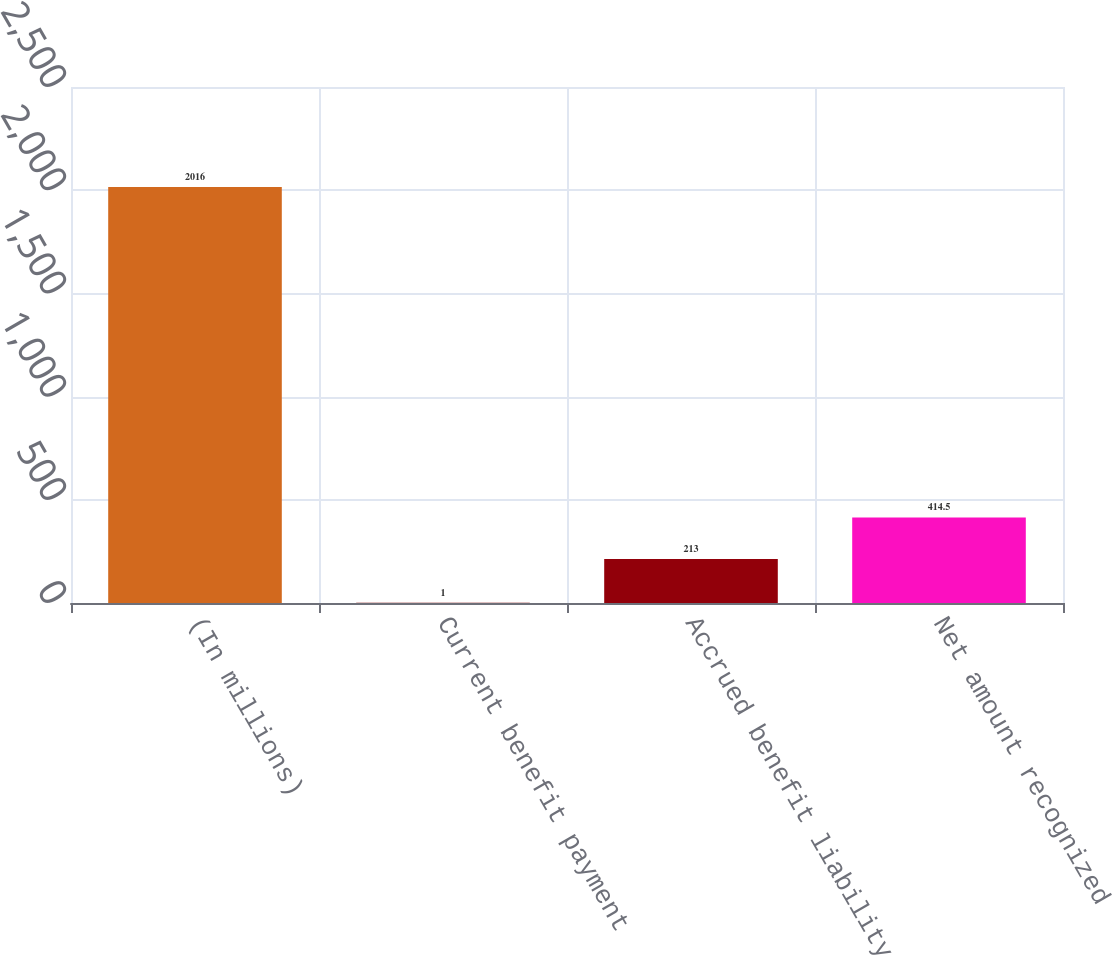Convert chart. <chart><loc_0><loc_0><loc_500><loc_500><bar_chart><fcel>(In millions)<fcel>Current benefit payment<fcel>Accrued benefit liability<fcel>Net amount recognized<nl><fcel>2016<fcel>1<fcel>213<fcel>414.5<nl></chart> 